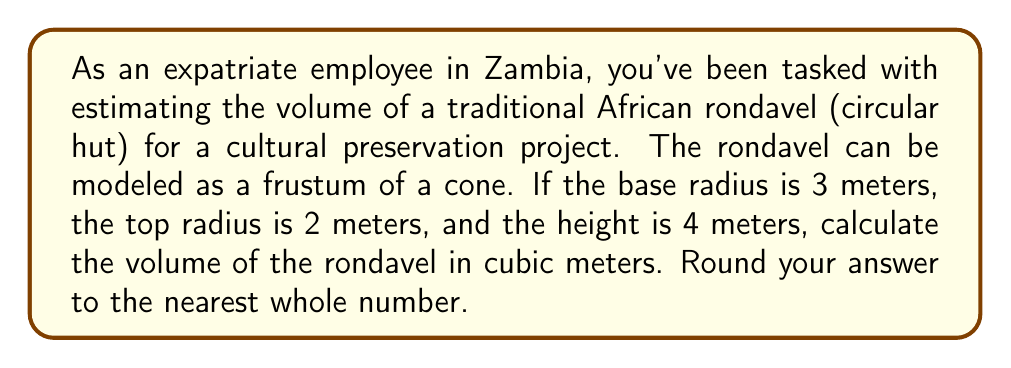Give your solution to this math problem. To solve this problem, we'll use the formula for the volume of a frustum of a cone:

$$V = \frac{1}{3}\pi h(R^2 + r^2 + Rr)$$

Where:
$V$ = volume
$h$ = height
$R$ = radius of the base
$r$ = radius of the top

Given:
$h = 4$ m
$R = 3$ m
$r = 2$ m

Let's substitute these values into the formula:

$$V = \frac{1}{3}\pi \cdot 4(3^2 + 2^2 + 3 \cdot 2)$$

Simplify the expressions inside the parentheses:
$$V = \frac{1}{3}\pi \cdot 4(9 + 4 + 6)$$
$$V = \frac{1}{3}\pi \cdot 4(19)$$

Multiply:
$$V = \frac{4}{3}\pi \cdot 19$$

Calculate:
$$V \approx 79.58 \text{ m}^3$$

Rounding to the nearest whole number:
$$V \approx 80 \text{ m}^3$$
Answer: 80 m³ 